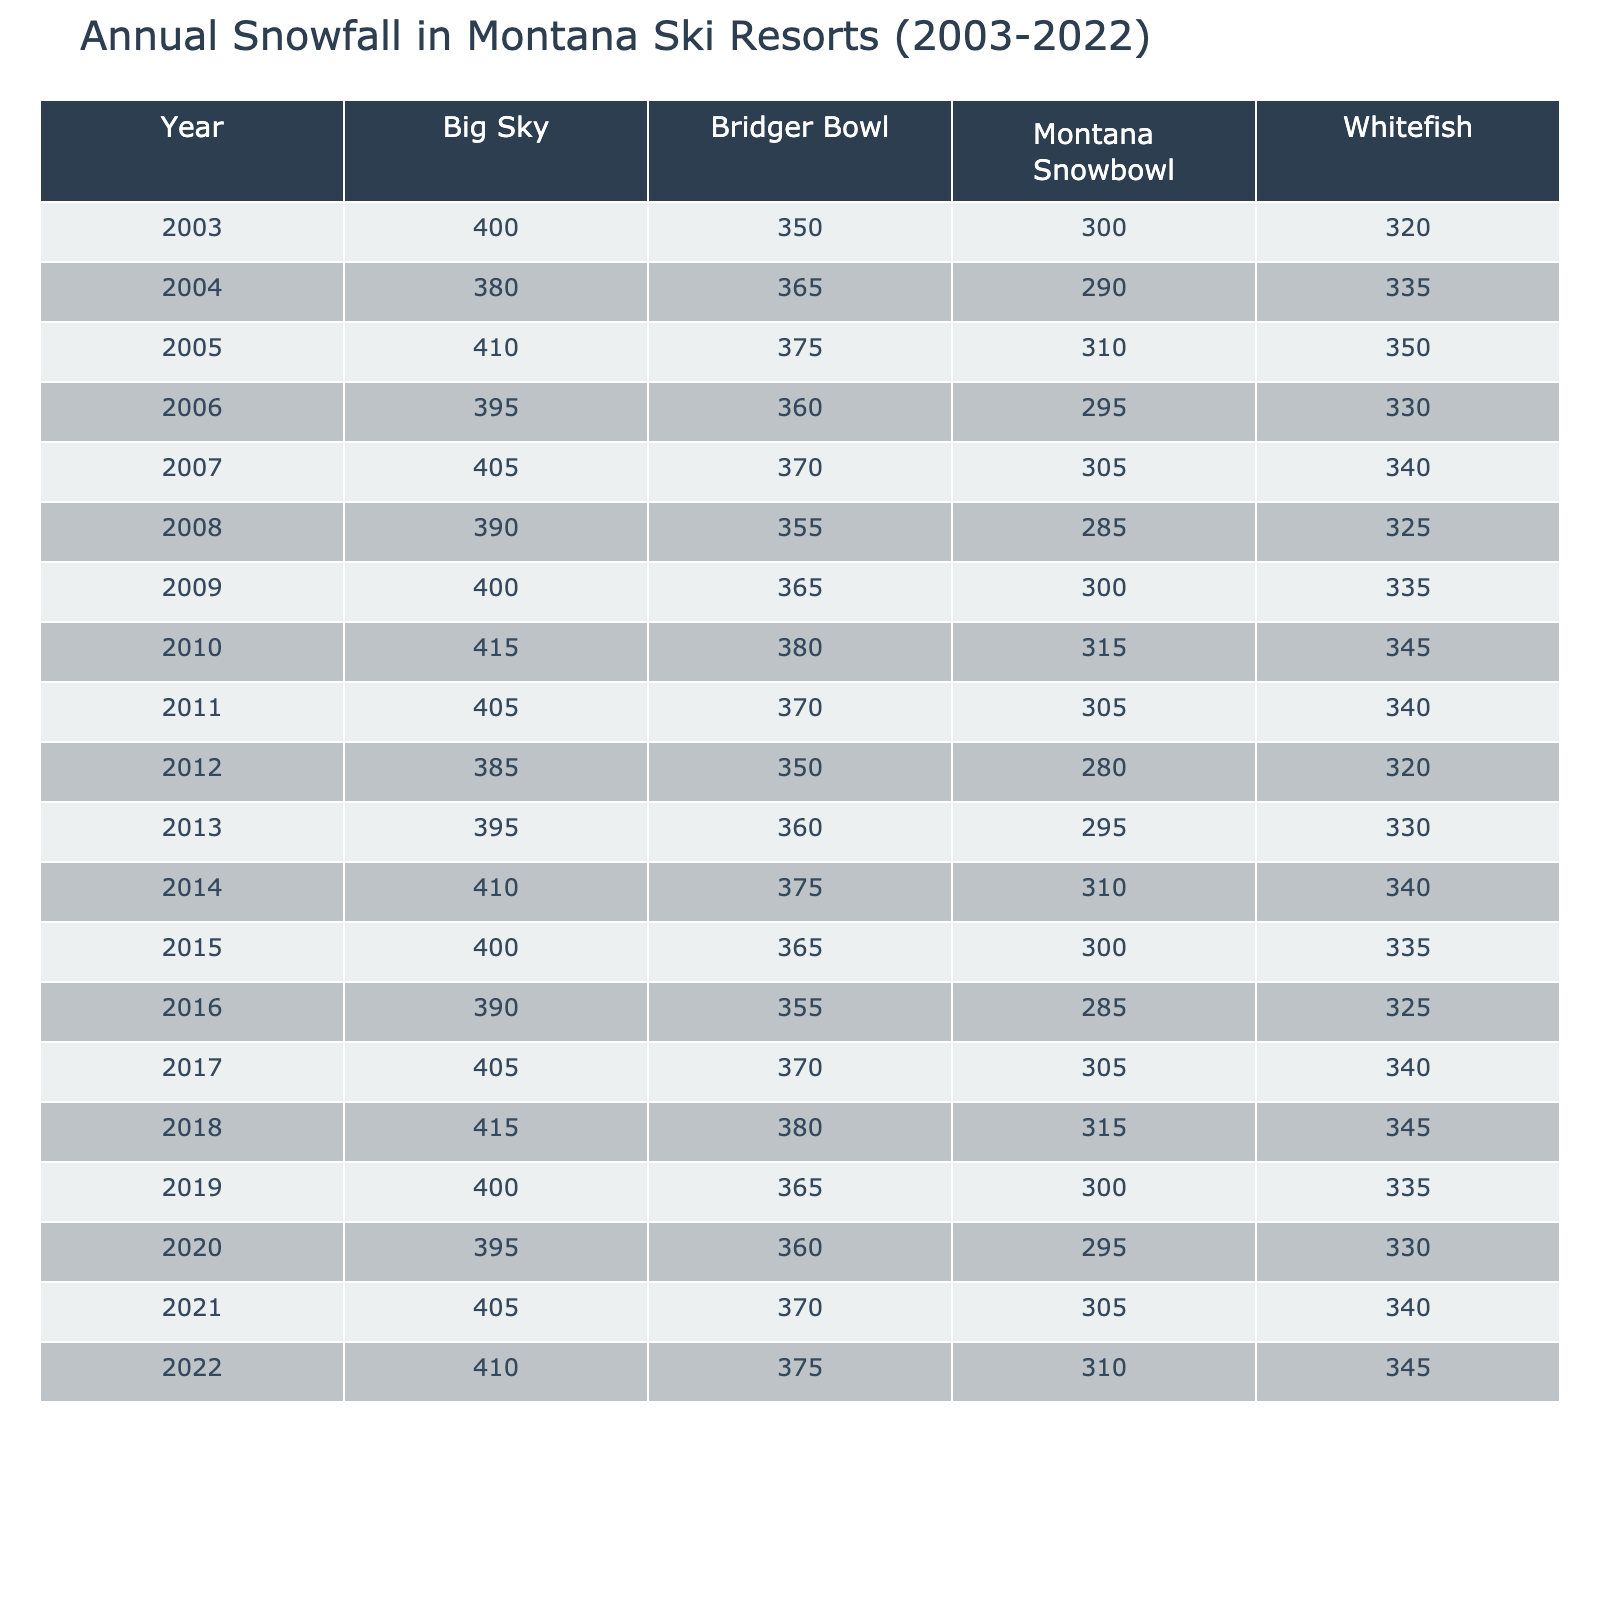What was the highest annual snowfall recorded at Big Sky? Looking at the table, we see that the highest annual snowfall recorded at Big Sky is 415 inches, which occurred in both 2010 and 2018.
Answer: 415 inches Which resort had the lowest annual snowfall in 2008? Referring to the table for the year 2008, Montana Snowbowl had the lowest annual snowfall among the resorts, measuring 285 inches.
Answer: Montana Snowbowl What is the average annual snowfall for Whitefish over the years 2003 to 2022? To calculate the average for Whitefish, we first sum the annual snowfall for each year: (320 + 335 + 350 + 340 + 325 + 345 + 330 + 335 + 345 + 340 + 320 + 325 + 340 + 335) = 4,080 inches. There are 14 data points, so we divide by 14 resulting in an average of 291.43 inches (rounded to two decimal places).
Answer: 291.43 inches Did Bridger Bowl have more than 370 inches of snowfall in 2021? Looking specifically at the table for the year 2021, Bridger Bowl recorded 370 inches of snowfall, which means it is not greater than 370 inches.
Answer: No What was the difference in annual snowfall between Big Sky and Montana Snowbowl in 2015? In 2015, Big Sky recorded 400 inches and Montana Snowbowl recorded 300 inches. The difference is calculated by subtracting Montana Snowbowl's snowfall from Big Sky's: 400 - 300 = 100 inches.
Answer: 100 inches How many times did Whitefish exceed 340 inches of snowfall over the 20 years? By examining each year in the table, Whitefish exceeded 340 inches in the years: 2005, 2010, 2011, 2018, and 2022, totaling 5 times.
Answer: 5 times Was there a consistent trend of increasing annual snowfall at any of the resorts throughout the 20-year period? Evaluating the data for trends in all resorts, we notice fluctuations rather than a consistent increase. Annual snowfall varies year by year with no clear upward trajectory across the period for any single resort.
Answer: No What is the total annual snowfall for all resorts combined in 2017? Adding the snowfall for each resort in 2017 gives us: (405 + 340 + 370 + 305) = 1420 inches.
Answer: 1420 inches In which year did Big Sky have snowfall that was below 400 inches for the first time? Scanning down the years, Big Sky had its first instance of snowfall below 400 inches in 2004, where it measured 380 inches.
Answer: 2004 What was the median annual snowfall recorded at Montana Snowbowl across all years? To find the median, we list the annual snowfall values for Montana Snowbowl: 285, 280, 295, 295, 300, 305, 310, 300, 310, 315, 305, 295, 290, 310. When ordered, the median falls between the 7th and 8th values in the sorted list (305 and 310), giving a median of 307.5 inches.
Answer: 307.5 inches 